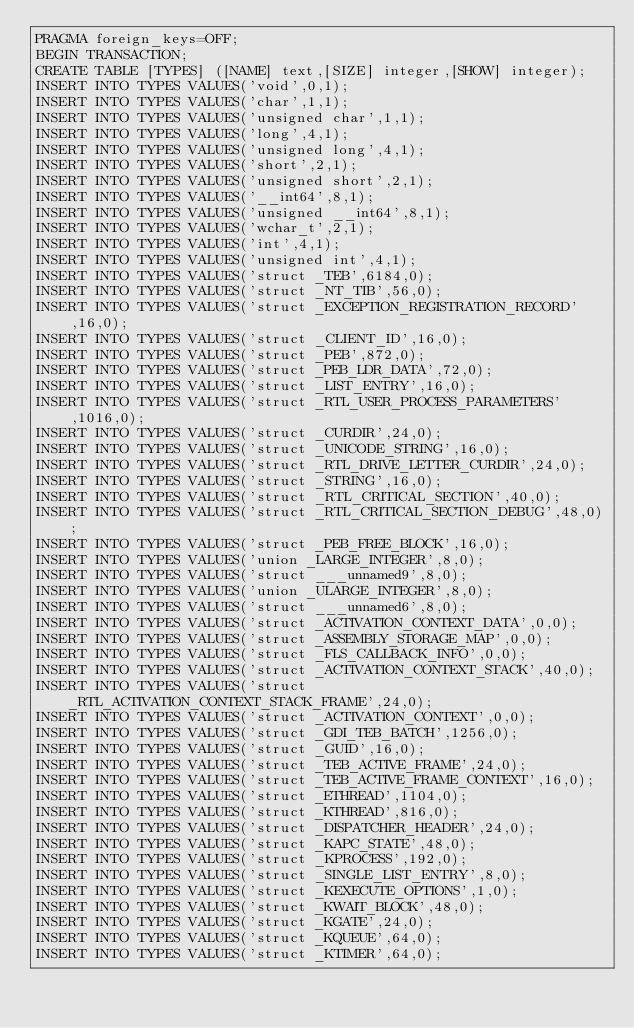<code> <loc_0><loc_0><loc_500><loc_500><_SQL_>PRAGMA foreign_keys=OFF;
BEGIN TRANSACTION;
CREATE TABLE [TYPES] ([NAME] text,[SIZE] integer,[SHOW] integer);
INSERT INTO TYPES VALUES('void',0,1);
INSERT INTO TYPES VALUES('char',1,1);
INSERT INTO TYPES VALUES('unsigned char',1,1);
INSERT INTO TYPES VALUES('long',4,1);
INSERT INTO TYPES VALUES('unsigned long',4,1);
INSERT INTO TYPES VALUES('short',2,1);
INSERT INTO TYPES VALUES('unsigned short',2,1);
INSERT INTO TYPES VALUES('__int64',8,1);
INSERT INTO TYPES VALUES('unsigned __int64',8,1);
INSERT INTO TYPES VALUES('wchar_t',2,1);
INSERT INTO TYPES VALUES('int',4,1);
INSERT INTO TYPES VALUES('unsigned int',4,1);
INSERT INTO TYPES VALUES('struct _TEB',6184,0);
INSERT INTO TYPES VALUES('struct _NT_TIB',56,0);
INSERT INTO TYPES VALUES('struct _EXCEPTION_REGISTRATION_RECORD',16,0);
INSERT INTO TYPES VALUES('struct _CLIENT_ID',16,0);
INSERT INTO TYPES VALUES('struct _PEB',872,0);
INSERT INTO TYPES VALUES('struct _PEB_LDR_DATA',72,0);
INSERT INTO TYPES VALUES('struct _LIST_ENTRY',16,0);
INSERT INTO TYPES VALUES('struct _RTL_USER_PROCESS_PARAMETERS',1016,0);
INSERT INTO TYPES VALUES('struct _CURDIR',24,0);
INSERT INTO TYPES VALUES('struct _UNICODE_STRING',16,0);
INSERT INTO TYPES VALUES('struct _RTL_DRIVE_LETTER_CURDIR',24,0);
INSERT INTO TYPES VALUES('struct _STRING',16,0);
INSERT INTO TYPES VALUES('struct _RTL_CRITICAL_SECTION',40,0);
INSERT INTO TYPES VALUES('struct _RTL_CRITICAL_SECTION_DEBUG',48,0);
INSERT INTO TYPES VALUES('struct _PEB_FREE_BLOCK',16,0);
INSERT INTO TYPES VALUES('union _LARGE_INTEGER',8,0);
INSERT INTO TYPES VALUES('struct ___unnamed9',8,0);
INSERT INTO TYPES VALUES('union _ULARGE_INTEGER',8,0);
INSERT INTO TYPES VALUES('struct ___unnamed6',8,0);
INSERT INTO TYPES VALUES('struct _ACTIVATION_CONTEXT_DATA',0,0);
INSERT INTO TYPES VALUES('struct _ASSEMBLY_STORAGE_MAP',0,0);
INSERT INTO TYPES VALUES('struct _FLS_CALLBACK_INFO',0,0);
INSERT INTO TYPES VALUES('struct _ACTIVATION_CONTEXT_STACK',40,0);
INSERT INTO TYPES VALUES('struct _RTL_ACTIVATION_CONTEXT_STACK_FRAME',24,0);
INSERT INTO TYPES VALUES('struct _ACTIVATION_CONTEXT',0,0);
INSERT INTO TYPES VALUES('struct _GDI_TEB_BATCH',1256,0);
INSERT INTO TYPES VALUES('struct _GUID',16,0);
INSERT INTO TYPES VALUES('struct _TEB_ACTIVE_FRAME',24,0);
INSERT INTO TYPES VALUES('struct _TEB_ACTIVE_FRAME_CONTEXT',16,0);
INSERT INTO TYPES VALUES('struct _ETHREAD',1104,0);
INSERT INTO TYPES VALUES('struct _KTHREAD',816,0);
INSERT INTO TYPES VALUES('struct _DISPATCHER_HEADER',24,0);
INSERT INTO TYPES VALUES('struct _KAPC_STATE',48,0);
INSERT INTO TYPES VALUES('struct _KPROCESS',192,0);
INSERT INTO TYPES VALUES('struct _SINGLE_LIST_ENTRY',8,0);
INSERT INTO TYPES VALUES('struct _KEXECUTE_OPTIONS',1,0);
INSERT INTO TYPES VALUES('struct _KWAIT_BLOCK',48,0);
INSERT INTO TYPES VALUES('struct _KGATE',24,0);
INSERT INTO TYPES VALUES('struct _KQUEUE',64,0);
INSERT INTO TYPES VALUES('struct _KTIMER',64,0);</code> 